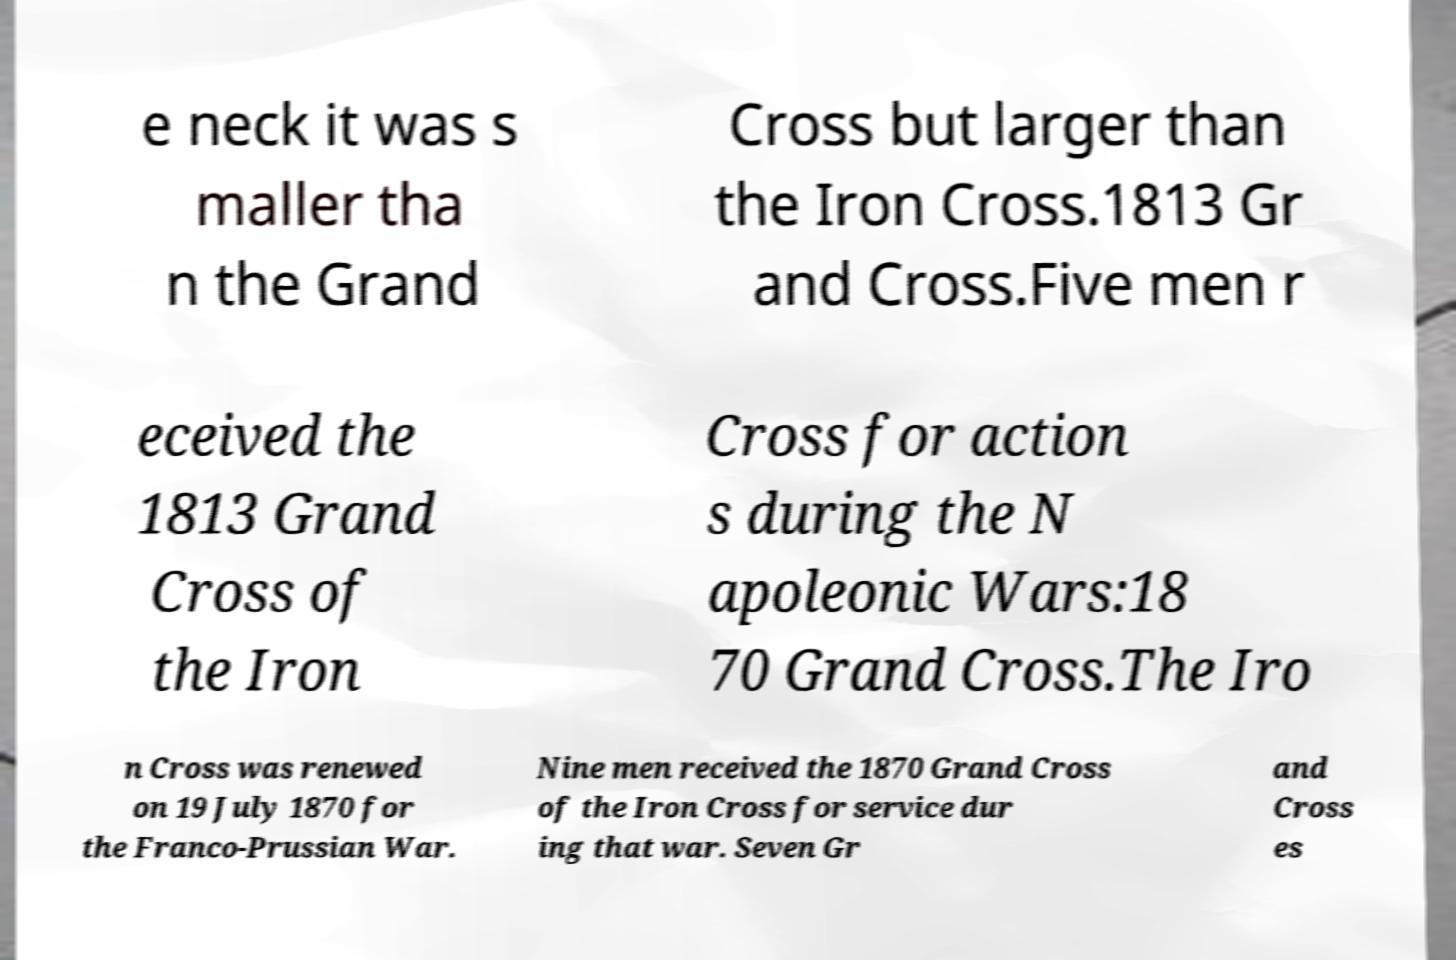Can you read and provide the text displayed in the image?This photo seems to have some interesting text. Can you extract and type it out for me? e neck it was s maller tha n the Grand Cross but larger than the Iron Cross.1813 Gr and Cross.Five men r eceived the 1813 Grand Cross of the Iron Cross for action s during the N apoleonic Wars:18 70 Grand Cross.The Iro n Cross was renewed on 19 July 1870 for the Franco-Prussian War. Nine men received the 1870 Grand Cross of the Iron Cross for service dur ing that war. Seven Gr and Cross es 